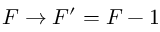Convert formula to latex. <formula><loc_0><loc_0><loc_500><loc_500>F \rightarrow F ^ { \prime } = F - 1</formula> 